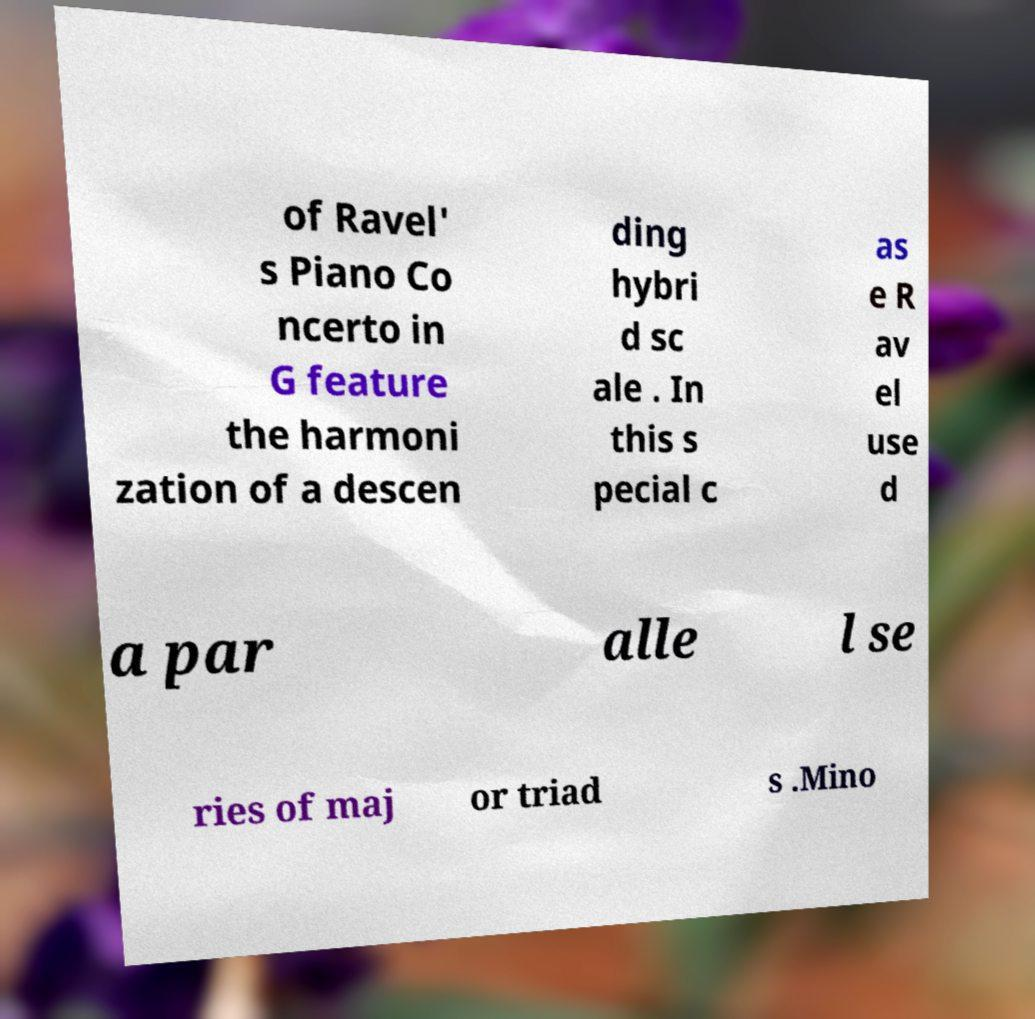What messages or text are displayed in this image? I need them in a readable, typed format. of Ravel' s Piano Co ncerto in G feature the harmoni zation of a descen ding hybri d sc ale . In this s pecial c as e R av el use d a par alle l se ries of maj or triad s .Mino 